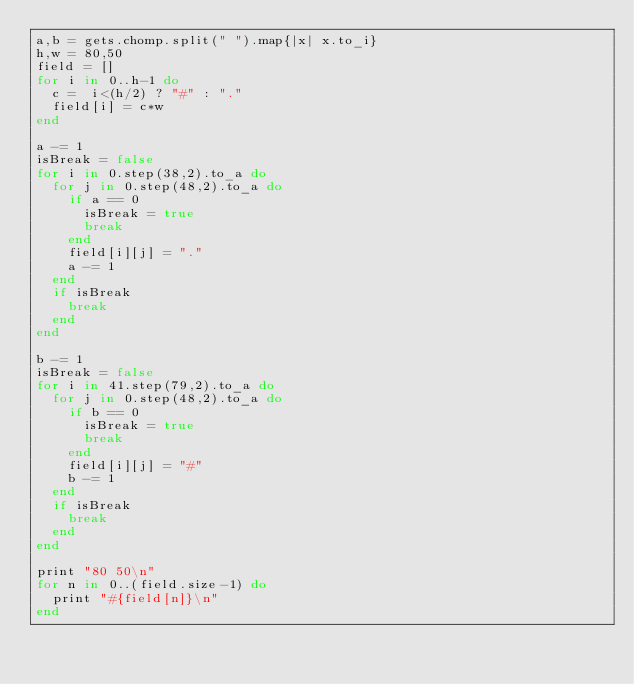<code> <loc_0><loc_0><loc_500><loc_500><_Ruby_>a,b = gets.chomp.split(" ").map{|x| x.to_i}
h,w = 80,50
field = []
for i in 0..h-1 do
  c =  i<(h/2) ? "#" : "."
  field[i] = c*w
end

a -= 1
isBreak = false
for i in 0.step(38,2).to_a do
  for j in 0.step(48,2).to_a do
    if a == 0
      isBreak = true
      break
    end
    field[i][j] = "."
    a -= 1
  end
  if isBreak
    break
  end
end

b -= 1
isBreak = false
for i in 41.step(79,2).to_a do
  for j in 0.step(48,2).to_a do
    if b == 0
      isBreak = true
      break
    end
    field[i][j] = "#"
    b -= 1
  end
  if isBreak
    break
  end
end

print "80 50\n"
for n in 0..(field.size-1) do 
  print "#{field[n]}\n" 
end</code> 